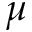<formula> <loc_0><loc_0><loc_500><loc_500>\mu</formula> 